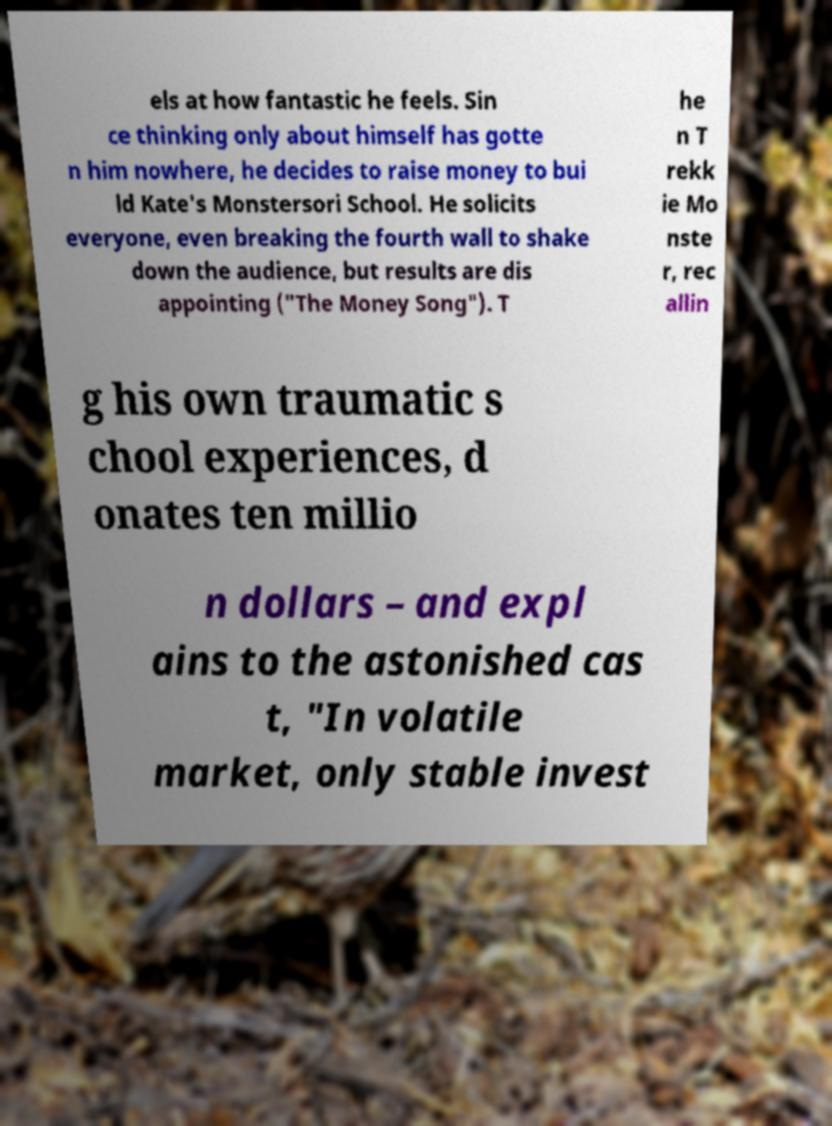I need the written content from this picture converted into text. Can you do that? els at how fantastic he feels. Sin ce thinking only about himself has gotte n him nowhere, he decides to raise money to bui ld Kate's Monstersori School. He solicits everyone, even breaking the fourth wall to shake down the audience, but results are dis appointing ("The Money Song"). T he n T rekk ie Mo nste r, rec allin g his own traumatic s chool experiences, d onates ten millio n dollars – and expl ains to the astonished cas t, "In volatile market, only stable invest 